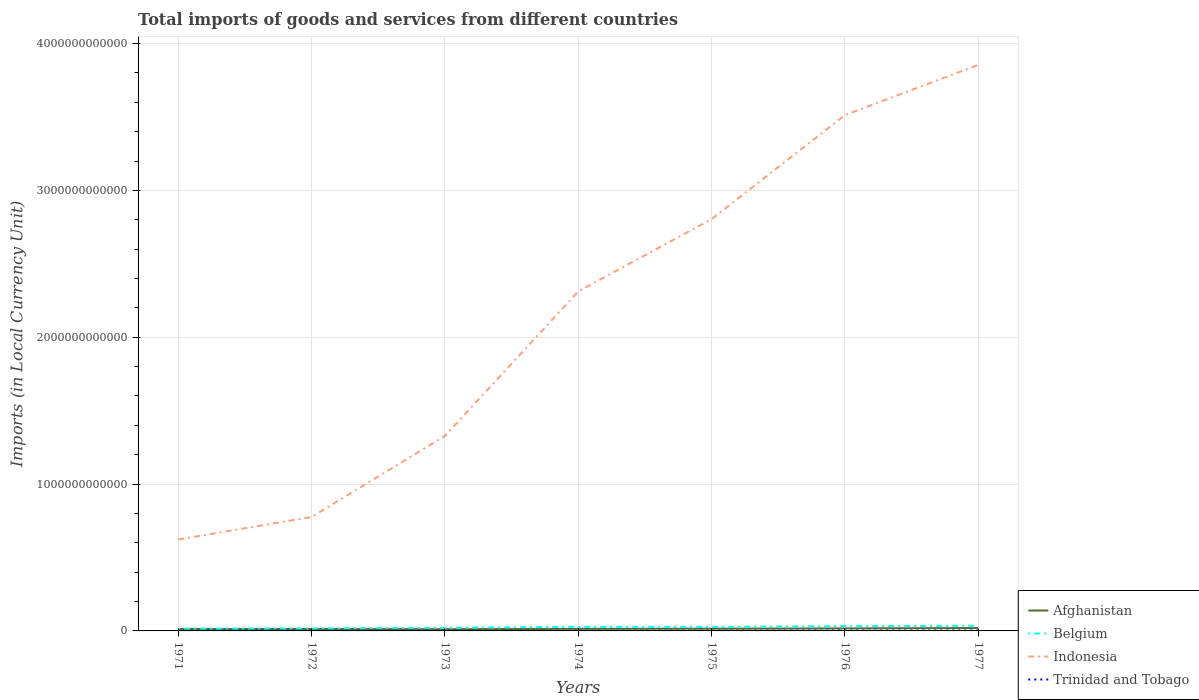How many different coloured lines are there?
Your response must be concise. 4. Across all years, what is the maximum Amount of goods and services imports in Trinidad and Tobago?
Provide a succinct answer. 8.48e+08. What is the total Amount of goods and services imports in Indonesia in the graph?
Your answer should be compact. -7.05e+11. What is the difference between the highest and the second highest Amount of goods and services imports in Trinidad and Tobago?
Keep it short and to the point. 1.93e+09. What is the difference between the highest and the lowest Amount of goods and services imports in Trinidad and Tobago?
Offer a very short reply. 3. Is the Amount of goods and services imports in Belgium strictly greater than the Amount of goods and services imports in Trinidad and Tobago over the years?
Your answer should be very brief. No. How many lines are there?
Make the answer very short. 4. How many years are there in the graph?
Ensure brevity in your answer.  7. What is the difference between two consecutive major ticks on the Y-axis?
Your answer should be compact. 1.00e+12. Does the graph contain any zero values?
Offer a very short reply. No. Does the graph contain grids?
Provide a short and direct response. Yes. What is the title of the graph?
Make the answer very short. Total imports of goods and services from different countries. What is the label or title of the Y-axis?
Ensure brevity in your answer.  Imports (in Local Currency Unit). What is the Imports (in Local Currency Unit) of Afghanistan in 1971?
Offer a terse response. 1.33e+1. What is the Imports (in Local Currency Unit) in Belgium in 1971?
Offer a very short reply. 1.52e+1. What is the Imports (in Local Currency Unit) of Indonesia in 1971?
Give a very brief answer. 6.22e+11. What is the Imports (in Local Currency Unit) of Trinidad and Tobago in 1971?
Ensure brevity in your answer.  8.48e+08. What is the Imports (in Local Currency Unit) in Afghanistan in 1972?
Your response must be concise. 1.30e+1. What is the Imports (in Local Currency Unit) in Belgium in 1972?
Ensure brevity in your answer.  1.67e+1. What is the Imports (in Local Currency Unit) in Indonesia in 1972?
Provide a short and direct response. 7.76e+11. What is the Imports (in Local Currency Unit) in Trinidad and Tobago in 1972?
Give a very brief answer. 9.63e+08. What is the Imports (in Local Currency Unit) in Afghanistan in 1973?
Give a very brief answer. 1.15e+1. What is the Imports (in Local Currency Unit) of Belgium in 1973?
Make the answer very short. 2.13e+1. What is the Imports (in Local Currency Unit) of Indonesia in 1973?
Provide a short and direct response. 1.33e+12. What is the Imports (in Local Currency Unit) of Trinidad and Tobago in 1973?
Offer a terse response. 9.84e+08. What is the Imports (in Local Currency Unit) of Afghanistan in 1974?
Your answer should be very brief. 1.44e+1. What is the Imports (in Local Currency Unit) in Belgium in 1974?
Give a very brief answer. 2.84e+1. What is the Imports (in Local Currency Unit) of Indonesia in 1974?
Offer a terse response. 2.31e+12. What is the Imports (in Local Currency Unit) in Trinidad and Tobago in 1974?
Your answer should be very brief. 1.35e+09. What is the Imports (in Local Currency Unit) in Afghanistan in 1975?
Your response must be concise. 1.52e+1. What is the Imports (in Local Currency Unit) in Belgium in 1975?
Provide a succinct answer. 2.73e+1. What is the Imports (in Local Currency Unit) of Indonesia in 1975?
Keep it short and to the point. 2.80e+12. What is the Imports (in Local Currency Unit) of Trinidad and Tobago in 1975?
Give a very brief answer. 1.87e+09. What is the Imports (in Local Currency Unit) in Afghanistan in 1976?
Give a very brief answer. 1.71e+1. What is the Imports (in Local Currency Unit) in Belgium in 1976?
Your response must be concise. 3.29e+1. What is the Imports (in Local Currency Unit) in Indonesia in 1976?
Provide a short and direct response. 3.51e+12. What is the Imports (in Local Currency Unit) in Trinidad and Tobago in 1976?
Your answer should be very brief. 2.44e+09. What is the Imports (in Local Currency Unit) of Afghanistan in 1977?
Your answer should be very brief. 1.97e+1. What is the Imports (in Local Currency Unit) of Belgium in 1977?
Provide a short and direct response. 3.55e+1. What is the Imports (in Local Currency Unit) in Indonesia in 1977?
Your answer should be very brief. 3.86e+12. What is the Imports (in Local Currency Unit) in Trinidad and Tobago in 1977?
Offer a terse response. 2.78e+09. Across all years, what is the maximum Imports (in Local Currency Unit) in Afghanistan?
Give a very brief answer. 1.97e+1. Across all years, what is the maximum Imports (in Local Currency Unit) in Belgium?
Offer a terse response. 3.55e+1. Across all years, what is the maximum Imports (in Local Currency Unit) in Indonesia?
Provide a succinct answer. 3.86e+12. Across all years, what is the maximum Imports (in Local Currency Unit) of Trinidad and Tobago?
Provide a short and direct response. 2.78e+09. Across all years, what is the minimum Imports (in Local Currency Unit) in Afghanistan?
Make the answer very short. 1.15e+1. Across all years, what is the minimum Imports (in Local Currency Unit) in Belgium?
Ensure brevity in your answer.  1.52e+1. Across all years, what is the minimum Imports (in Local Currency Unit) in Indonesia?
Give a very brief answer. 6.22e+11. Across all years, what is the minimum Imports (in Local Currency Unit) of Trinidad and Tobago?
Make the answer very short. 8.48e+08. What is the total Imports (in Local Currency Unit) of Afghanistan in the graph?
Give a very brief answer. 1.04e+11. What is the total Imports (in Local Currency Unit) of Belgium in the graph?
Keep it short and to the point. 1.77e+11. What is the total Imports (in Local Currency Unit) in Indonesia in the graph?
Offer a terse response. 1.52e+13. What is the total Imports (in Local Currency Unit) of Trinidad and Tobago in the graph?
Offer a very short reply. 1.12e+1. What is the difference between the Imports (in Local Currency Unit) in Afghanistan in 1971 and that in 1972?
Provide a short and direct response. 3.00e+08. What is the difference between the Imports (in Local Currency Unit) of Belgium in 1971 and that in 1972?
Offer a very short reply. -1.51e+09. What is the difference between the Imports (in Local Currency Unit) in Indonesia in 1971 and that in 1972?
Offer a very short reply. -1.54e+11. What is the difference between the Imports (in Local Currency Unit) in Trinidad and Tobago in 1971 and that in 1972?
Your response must be concise. -1.15e+08. What is the difference between the Imports (in Local Currency Unit) in Afghanistan in 1971 and that in 1973?
Make the answer very short. 1.80e+09. What is the difference between the Imports (in Local Currency Unit) in Belgium in 1971 and that in 1973?
Offer a very short reply. -6.11e+09. What is the difference between the Imports (in Local Currency Unit) of Indonesia in 1971 and that in 1973?
Your answer should be compact. -7.05e+11. What is the difference between the Imports (in Local Currency Unit) of Trinidad and Tobago in 1971 and that in 1973?
Provide a short and direct response. -1.36e+08. What is the difference between the Imports (in Local Currency Unit) of Afghanistan in 1971 and that in 1974?
Make the answer very short. -1.10e+09. What is the difference between the Imports (in Local Currency Unit) of Belgium in 1971 and that in 1974?
Offer a terse response. -1.32e+1. What is the difference between the Imports (in Local Currency Unit) of Indonesia in 1971 and that in 1974?
Provide a short and direct response. -1.69e+12. What is the difference between the Imports (in Local Currency Unit) of Trinidad and Tobago in 1971 and that in 1974?
Provide a short and direct response. -5.01e+08. What is the difference between the Imports (in Local Currency Unit) of Afghanistan in 1971 and that in 1975?
Give a very brief answer. -1.90e+09. What is the difference between the Imports (in Local Currency Unit) in Belgium in 1971 and that in 1975?
Make the answer very short. -1.22e+1. What is the difference between the Imports (in Local Currency Unit) in Indonesia in 1971 and that in 1975?
Keep it short and to the point. -2.18e+12. What is the difference between the Imports (in Local Currency Unit) in Trinidad and Tobago in 1971 and that in 1975?
Ensure brevity in your answer.  -1.02e+09. What is the difference between the Imports (in Local Currency Unit) of Afghanistan in 1971 and that in 1976?
Offer a very short reply. -3.80e+09. What is the difference between the Imports (in Local Currency Unit) of Belgium in 1971 and that in 1976?
Keep it short and to the point. -1.77e+1. What is the difference between the Imports (in Local Currency Unit) in Indonesia in 1971 and that in 1976?
Offer a very short reply. -2.89e+12. What is the difference between the Imports (in Local Currency Unit) in Trinidad and Tobago in 1971 and that in 1976?
Give a very brief answer. -1.60e+09. What is the difference between the Imports (in Local Currency Unit) of Afghanistan in 1971 and that in 1977?
Provide a succinct answer. -6.40e+09. What is the difference between the Imports (in Local Currency Unit) of Belgium in 1971 and that in 1977?
Offer a terse response. -2.03e+1. What is the difference between the Imports (in Local Currency Unit) in Indonesia in 1971 and that in 1977?
Offer a terse response. -3.23e+12. What is the difference between the Imports (in Local Currency Unit) in Trinidad and Tobago in 1971 and that in 1977?
Your response must be concise. -1.93e+09. What is the difference between the Imports (in Local Currency Unit) of Afghanistan in 1972 and that in 1973?
Your response must be concise. 1.50e+09. What is the difference between the Imports (in Local Currency Unit) of Belgium in 1972 and that in 1973?
Keep it short and to the point. -4.60e+09. What is the difference between the Imports (in Local Currency Unit) of Indonesia in 1972 and that in 1973?
Offer a terse response. -5.52e+11. What is the difference between the Imports (in Local Currency Unit) in Trinidad and Tobago in 1972 and that in 1973?
Give a very brief answer. -2.09e+07. What is the difference between the Imports (in Local Currency Unit) in Afghanistan in 1972 and that in 1974?
Keep it short and to the point. -1.40e+09. What is the difference between the Imports (in Local Currency Unit) in Belgium in 1972 and that in 1974?
Offer a very short reply. -1.17e+1. What is the difference between the Imports (in Local Currency Unit) in Indonesia in 1972 and that in 1974?
Offer a very short reply. -1.54e+12. What is the difference between the Imports (in Local Currency Unit) in Trinidad and Tobago in 1972 and that in 1974?
Offer a terse response. -3.87e+08. What is the difference between the Imports (in Local Currency Unit) in Afghanistan in 1972 and that in 1975?
Give a very brief answer. -2.20e+09. What is the difference between the Imports (in Local Currency Unit) of Belgium in 1972 and that in 1975?
Make the answer very short. -1.06e+1. What is the difference between the Imports (in Local Currency Unit) of Indonesia in 1972 and that in 1975?
Your answer should be compact. -2.03e+12. What is the difference between the Imports (in Local Currency Unit) of Trinidad and Tobago in 1972 and that in 1975?
Give a very brief answer. -9.03e+08. What is the difference between the Imports (in Local Currency Unit) in Afghanistan in 1972 and that in 1976?
Give a very brief answer. -4.10e+09. What is the difference between the Imports (in Local Currency Unit) of Belgium in 1972 and that in 1976?
Offer a terse response. -1.62e+1. What is the difference between the Imports (in Local Currency Unit) of Indonesia in 1972 and that in 1976?
Provide a short and direct response. -2.74e+12. What is the difference between the Imports (in Local Currency Unit) in Trinidad and Tobago in 1972 and that in 1976?
Keep it short and to the point. -1.48e+09. What is the difference between the Imports (in Local Currency Unit) in Afghanistan in 1972 and that in 1977?
Offer a terse response. -6.70e+09. What is the difference between the Imports (in Local Currency Unit) of Belgium in 1972 and that in 1977?
Make the answer very short. -1.88e+1. What is the difference between the Imports (in Local Currency Unit) of Indonesia in 1972 and that in 1977?
Your response must be concise. -3.08e+12. What is the difference between the Imports (in Local Currency Unit) in Trinidad and Tobago in 1972 and that in 1977?
Ensure brevity in your answer.  -1.82e+09. What is the difference between the Imports (in Local Currency Unit) in Afghanistan in 1973 and that in 1974?
Offer a very short reply. -2.90e+09. What is the difference between the Imports (in Local Currency Unit) in Belgium in 1973 and that in 1974?
Provide a succinct answer. -7.08e+09. What is the difference between the Imports (in Local Currency Unit) in Indonesia in 1973 and that in 1974?
Your response must be concise. -9.84e+11. What is the difference between the Imports (in Local Currency Unit) of Trinidad and Tobago in 1973 and that in 1974?
Offer a very short reply. -3.66e+08. What is the difference between the Imports (in Local Currency Unit) of Afghanistan in 1973 and that in 1975?
Your response must be concise. -3.70e+09. What is the difference between the Imports (in Local Currency Unit) of Belgium in 1973 and that in 1975?
Ensure brevity in your answer.  -6.04e+09. What is the difference between the Imports (in Local Currency Unit) of Indonesia in 1973 and that in 1975?
Ensure brevity in your answer.  -1.48e+12. What is the difference between the Imports (in Local Currency Unit) in Trinidad and Tobago in 1973 and that in 1975?
Your answer should be very brief. -8.82e+08. What is the difference between the Imports (in Local Currency Unit) in Afghanistan in 1973 and that in 1976?
Ensure brevity in your answer.  -5.60e+09. What is the difference between the Imports (in Local Currency Unit) in Belgium in 1973 and that in 1976?
Make the answer very short. -1.16e+1. What is the difference between the Imports (in Local Currency Unit) of Indonesia in 1973 and that in 1976?
Your answer should be very brief. -2.19e+12. What is the difference between the Imports (in Local Currency Unit) of Trinidad and Tobago in 1973 and that in 1976?
Offer a very short reply. -1.46e+09. What is the difference between the Imports (in Local Currency Unit) in Afghanistan in 1973 and that in 1977?
Provide a succinct answer. -8.20e+09. What is the difference between the Imports (in Local Currency Unit) of Belgium in 1973 and that in 1977?
Give a very brief answer. -1.42e+1. What is the difference between the Imports (in Local Currency Unit) in Indonesia in 1973 and that in 1977?
Ensure brevity in your answer.  -2.53e+12. What is the difference between the Imports (in Local Currency Unit) of Trinidad and Tobago in 1973 and that in 1977?
Keep it short and to the point. -1.80e+09. What is the difference between the Imports (in Local Currency Unit) in Afghanistan in 1974 and that in 1975?
Offer a terse response. -8.00e+08. What is the difference between the Imports (in Local Currency Unit) in Belgium in 1974 and that in 1975?
Your answer should be compact. 1.03e+09. What is the difference between the Imports (in Local Currency Unit) of Indonesia in 1974 and that in 1975?
Your answer should be compact. -4.93e+11. What is the difference between the Imports (in Local Currency Unit) of Trinidad and Tobago in 1974 and that in 1975?
Offer a terse response. -5.16e+08. What is the difference between the Imports (in Local Currency Unit) in Afghanistan in 1974 and that in 1976?
Your answer should be very brief. -2.70e+09. What is the difference between the Imports (in Local Currency Unit) of Belgium in 1974 and that in 1976?
Your answer should be very brief. -4.51e+09. What is the difference between the Imports (in Local Currency Unit) in Indonesia in 1974 and that in 1976?
Offer a very short reply. -1.20e+12. What is the difference between the Imports (in Local Currency Unit) of Trinidad and Tobago in 1974 and that in 1976?
Provide a succinct answer. -1.10e+09. What is the difference between the Imports (in Local Currency Unit) in Afghanistan in 1974 and that in 1977?
Keep it short and to the point. -5.30e+09. What is the difference between the Imports (in Local Currency Unit) of Belgium in 1974 and that in 1977?
Keep it short and to the point. -7.12e+09. What is the difference between the Imports (in Local Currency Unit) of Indonesia in 1974 and that in 1977?
Give a very brief answer. -1.54e+12. What is the difference between the Imports (in Local Currency Unit) of Trinidad and Tobago in 1974 and that in 1977?
Offer a terse response. -1.43e+09. What is the difference between the Imports (in Local Currency Unit) in Afghanistan in 1975 and that in 1976?
Offer a very short reply. -1.90e+09. What is the difference between the Imports (in Local Currency Unit) of Belgium in 1975 and that in 1976?
Your response must be concise. -5.54e+09. What is the difference between the Imports (in Local Currency Unit) in Indonesia in 1975 and that in 1976?
Your response must be concise. -7.08e+11. What is the difference between the Imports (in Local Currency Unit) in Trinidad and Tobago in 1975 and that in 1976?
Your response must be concise. -5.79e+08. What is the difference between the Imports (in Local Currency Unit) in Afghanistan in 1975 and that in 1977?
Offer a terse response. -4.50e+09. What is the difference between the Imports (in Local Currency Unit) in Belgium in 1975 and that in 1977?
Your response must be concise. -8.15e+09. What is the difference between the Imports (in Local Currency Unit) of Indonesia in 1975 and that in 1977?
Make the answer very short. -1.05e+12. What is the difference between the Imports (in Local Currency Unit) in Trinidad and Tobago in 1975 and that in 1977?
Offer a very short reply. -9.14e+08. What is the difference between the Imports (in Local Currency Unit) in Afghanistan in 1976 and that in 1977?
Your answer should be compact. -2.60e+09. What is the difference between the Imports (in Local Currency Unit) in Belgium in 1976 and that in 1977?
Your answer should be compact. -2.61e+09. What is the difference between the Imports (in Local Currency Unit) of Indonesia in 1976 and that in 1977?
Provide a short and direct response. -3.42e+11. What is the difference between the Imports (in Local Currency Unit) in Trinidad and Tobago in 1976 and that in 1977?
Your answer should be very brief. -3.35e+08. What is the difference between the Imports (in Local Currency Unit) of Afghanistan in 1971 and the Imports (in Local Currency Unit) of Belgium in 1972?
Ensure brevity in your answer.  -3.39e+09. What is the difference between the Imports (in Local Currency Unit) in Afghanistan in 1971 and the Imports (in Local Currency Unit) in Indonesia in 1972?
Offer a terse response. -7.63e+11. What is the difference between the Imports (in Local Currency Unit) of Afghanistan in 1971 and the Imports (in Local Currency Unit) of Trinidad and Tobago in 1972?
Keep it short and to the point. 1.23e+1. What is the difference between the Imports (in Local Currency Unit) of Belgium in 1971 and the Imports (in Local Currency Unit) of Indonesia in 1972?
Your answer should be compact. -7.61e+11. What is the difference between the Imports (in Local Currency Unit) in Belgium in 1971 and the Imports (in Local Currency Unit) in Trinidad and Tobago in 1972?
Give a very brief answer. 1.42e+1. What is the difference between the Imports (in Local Currency Unit) in Indonesia in 1971 and the Imports (in Local Currency Unit) in Trinidad and Tobago in 1972?
Your answer should be very brief. 6.21e+11. What is the difference between the Imports (in Local Currency Unit) in Afghanistan in 1971 and the Imports (in Local Currency Unit) in Belgium in 1973?
Your answer should be very brief. -7.99e+09. What is the difference between the Imports (in Local Currency Unit) in Afghanistan in 1971 and the Imports (in Local Currency Unit) in Indonesia in 1973?
Keep it short and to the point. -1.31e+12. What is the difference between the Imports (in Local Currency Unit) in Afghanistan in 1971 and the Imports (in Local Currency Unit) in Trinidad and Tobago in 1973?
Make the answer very short. 1.23e+1. What is the difference between the Imports (in Local Currency Unit) of Belgium in 1971 and the Imports (in Local Currency Unit) of Indonesia in 1973?
Your response must be concise. -1.31e+12. What is the difference between the Imports (in Local Currency Unit) in Belgium in 1971 and the Imports (in Local Currency Unit) in Trinidad and Tobago in 1973?
Your answer should be very brief. 1.42e+1. What is the difference between the Imports (in Local Currency Unit) in Indonesia in 1971 and the Imports (in Local Currency Unit) in Trinidad and Tobago in 1973?
Your answer should be very brief. 6.21e+11. What is the difference between the Imports (in Local Currency Unit) in Afghanistan in 1971 and the Imports (in Local Currency Unit) in Belgium in 1974?
Offer a very short reply. -1.51e+1. What is the difference between the Imports (in Local Currency Unit) in Afghanistan in 1971 and the Imports (in Local Currency Unit) in Indonesia in 1974?
Offer a very short reply. -2.30e+12. What is the difference between the Imports (in Local Currency Unit) in Afghanistan in 1971 and the Imports (in Local Currency Unit) in Trinidad and Tobago in 1974?
Ensure brevity in your answer.  1.20e+1. What is the difference between the Imports (in Local Currency Unit) of Belgium in 1971 and the Imports (in Local Currency Unit) of Indonesia in 1974?
Offer a very short reply. -2.30e+12. What is the difference between the Imports (in Local Currency Unit) of Belgium in 1971 and the Imports (in Local Currency Unit) of Trinidad and Tobago in 1974?
Provide a short and direct response. 1.38e+1. What is the difference between the Imports (in Local Currency Unit) in Indonesia in 1971 and the Imports (in Local Currency Unit) in Trinidad and Tobago in 1974?
Give a very brief answer. 6.21e+11. What is the difference between the Imports (in Local Currency Unit) of Afghanistan in 1971 and the Imports (in Local Currency Unit) of Belgium in 1975?
Offer a very short reply. -1.40e+1. What is the difference between the Imports (in Local Currency Unit) of Afghanistan in 1971 and the Imports (in Local Currency Unit) of Indonesia in 1975?
Give a very brief answer. -2.79e+12. What is the difference between the Imports (in Local Currency Unit) in Afghanistan in 1971 and the Imports (in Local Currency Unit) in Trinidad and Tobago in 1975?
Ensure brevity in your answer.  1.14e+1. What is the difference between the Imports (in Local Currency Unit) of Belgium in 1971 and the Imports (in Local Currency Unit) of Indonesia in 1975?
Your answer should be compact. -2.79e+12. What is the difference between the Imports (in Local Currency Unit) in Belgium in 1971 and the Imports (in Local Currency Unit) in Trinidad and Tobago in 1975?
Your response must be concise. 1.33e+1. What is the difference between the Imports (in Local Currency Unit) in Indonesia in 1971 and the Imports (in Local Currency Unit) in Trinidad and Tobago in 1975?
Your response must be concise. 6.21e+11. What is the difference between the Imports (in Local Currency Unit) in Afghanistan in 1971 and the Imports (in Local Currency Unit) in Belgium in 1976?
Ensure brevity in your answer.  -1.96e+1. What is the difference between the Imports (in Local Currency Unit) in Afghanistan in 1971 and the Imports (in Local Currency Unit) in Indonesia in 1976?
Your answer should be very brief. -3.50e+12. What is the difference between the Imports (in Local Currency Unit) in Afghanistan in 1971 and the Imports (in Local Currency Unit) in Trinidad and Tobago in 1976?
Your answer should be compact. 1.09e+1. What is the difference between the Imports (in Local Currency Unit) in Belgium in 1971 and the Imports (in Local Currency Unit) in Indonesia in 1976?
Offer a very short reply. -3.50e+12. What is the difference between the Imports (in Local Currency Unit) in Belgium in 1971 and the Imports (in Local Currency Unit) in Trinidad and Tobago in 1976?
Your answer should be compact. 1.27e+1. What is the difference between the Imports (in Local Currency Unit) of Indonesia in 1971 and the Imports (in Local Currency Unit) of Trinidad and Tobago in 1976?
Provide a succinct answer. 6.20e+11. What is the difference between the Imports (in Local Currency Unit) of Afghanistan in 1971 and the Imports (in Local Currency Unit) of Belgium in 1977?
Give a very brief answer. -2.22e+1. What is the difference between the Imports (in Local Currency Unit) of Afghanistan in 1971 and the Imports (in Local Currency Unit) of Indonesia in 1977?
Your answer should be compact. -3.84e+12. What is the difference between the Imports (in Local Currency Unit) in Afghanistan in 1971 and the Imports (in Local Currency Unit) in Trinidad and Tobago in 1977?
Your answer should be compact. 1.05e+1. What is the difference between the Imports (in Local Currency Unit) in Belgium in 1971 and the Imports (in Local Currency Unit) in Indonesia in 1977?
Give a very brief answer. -3.84e+12. What is the difference between the Imports (in Local Currency Unit) in Belgium in 1971 and the Imports (in Local Currency Unit) in Trinidad and Tobago in 1977?
Offer a terse response. 1.24e+1. What is the difference between the Imports (in Local Currency Unit) of Indonesia in 1971 and the Imports (in Local Currency Unit) of Trinidad and Tobago in 1977?
Your response must be concise. 6.20e+11. What is the difference between the Imports (in Local Currency Unit) in Afghanistan in 1972 and the Imports (in Local Currency Unit) in Belgium in 1973?
Make the answer very short. -8.29e+09. What is the difference between the Imports (in Local Currency Unit) in Afghanistan in 1972 and the Imports (in Local Currency Unit) in Indonesia in 1973?
Ensure brevity in your answer.  -1.31e+12. What is the difference between the Imports (in Local Currency Unit) of Afghanistan in 1972 and the Imports (in Local Currency Unit) of Trinidad and Tobago in 1973?
Keep it short and to the point. 1.20e+1. What is the difference between the Imports (in Local Currency Unit) in Belgium in 1972 and the Imports (in Local Currency Unit) in Indonesia in 1973?
Ensure brevity in your answer.  -1.31e+12. What is the difference between the Imports (in Local Currency Unit) of Belgium in 1972 and the Imports (in Local Currency Unit) of Trinidad and Tobago in 1973?
Your answer should be compact. 1.57e+1. What is the difference between the Imports (in Local Currency Unit) of Indonesia in 1972 and the Imports (in Local Currency Unit) of Trinidad and Tobago in 1973?
Make the answer very short. 7.75e+11. What is the difference between the Imports (in Local Currency Unit) of Afghanistan in 1972 and the Imports (in Local Currency Unit) of Belgium in 1974?
Keep it short and to the point. -1.54e+1. What is the difference between the Imports (in Local Currency Unit) of Afghanistan in 1972 and the Imports (in Local Currency Unit) of Indonesia in 1974?
Make the answer very short. -2.30e+12. What is the difference between the Imports (in Local Currency Unit) of Afghanistan in 1972 and the Imports (in Local Currency Unit) of Trinidad and Tobago in 1974?
Offer a terse response. 1.17e+1. What is the difference between the Imports (in Local Currency Unit) in Belgium in 1972 and the Imports (in Local Currency Unit) in Indonesia in 1974?
Give a very brief answer. -2.30e+12. What is the difference between the Imports (in Local Currency Unit) in Belgium in 1972 and the Imports (in Local Currency Unit) in Trinidad and Tobago in 1974?
Give a very brief answer. 1.53e+1. What is the difference between the Imports (in Local Currency Unit) of Indonesia in 1972 and the Imports (in Local Currency Unit) of Trinidad and Tobago in 1974?
Provide a succinct answer. 7.75e+11. What is the difference between the Imports (in Local Currency Unit) of Afghanistan in 1972 and the Imports (in Local Currency Unit) of Belgium in 1975?
Provide a short and direct response. -1.43e+1. What is the difference between the Imports (in Local Currency Unit) of Afghanistan in 1972 and the Imports (in Local Currency Unit) of Indonesia in 1975?
Your response must be concise. -2.79e+12. What is the difference between the Imports (in Local Currency Unit) in Afghanistan in 1972 and the Imports (in Local Currency Unit) in Trinidad and Tobago in 1975?
Your answer should be compact. 1.11e+1. What is the difference between the Imports (in Local Currency Unit) in Belgium in 1972 and the Imports (in Local Currency Unit) in Indonesia in 1975?
Provide a short and direct response. -2.79e+12. What is the difference between the Imports (in Local Currency Unit) of Belgium in 1972 and the Imports (in Local Currency Unit) of Trinidad and Tobago in 1975?
Provide a short and direct response. 1.48e+1. What is the difference between the Imports (in Local Currency Unit) of Indonesia in 1972 and the Imports (in Local Currency Unit) of Trinidad and Tobago in 1975?
Ensure brevity in your answer.  7.74e+11. What is the difference between the Imports (in Local Currency Unit) of Afghanistan in 1972 and the Imports (in Local Currency Unit) of Belgium in 1976?
Provide a short and direct response. -1.99e+1. What is the difference between the Imports (in Local Currency Unit) in Afghanistan in 1972 and the Imports (in Local Currency Unit) in Indonesia in 1976?
Your answer should be very brief. -3.50e+12. What is the difference between the Imports (in Local Currency Unit) of Afghanistan in 1972 and the Imports (in Local Currency Unit) of Trinidad and Tobago in 1976?
Provide a succinct answer. 1.06e+1. What is the difference between the Imports (in Local Currency Unit) in Belgium in 1972 and the Imports (in Local Currency Unit) in Indonesia in 1976?
Your answer should be very brief. -3.50e+12. What is the difference between the Imports (in Local Currency Unit) in Belgium in 1972 and the Imports (in Local Currency Unit) in Trinidad and Tobago in 1976?
Give a very brief answer. 1.42e+1. What is the difference between the Imports (in Local Currency Unit) in Indonesia in 1972 and the Imports (in Local Currency Unit) in Trinidad and Tobago in 1976?
Offer a terse response. 7.74e+11. What is the difference between the Imports (in Local Currency Unit) of Afghanistan in 1972 and the Imports (in Local Currency Unit) of Belgium in 1977?
Keep it short and to the point. -2.25e+1. What is the difference between the Imports (in Local Currency Unit) in Afghanistan in 1972 and the Imports (in Local Currency Unit) in Indonesia in 1977?
Your answer should be compact. -3.84e+12. What is the difference between the Imports (in Local Currency Unit) of Afghanistan in 1972 and the Imports (in Local Currency Unit) of Trinidad and Tobago in 1977?
Make the answer very short. 1.02e+1. What is the difference between the Imports (in Local Currency Unit) in Belgium in 1972 and the Imports (in Local Currency Unit) in Indonesia in 1977?
Your answer should be compact. -3.84e+12. What is the difference between the Imports (in Local Currency Unit) in Belgium in 1972 and the Imports (in Local Currency Unit) in Trinidad and Tobago in 1977?
Your response must be concise. 1.39e+1. What is the difference between the Imports (in Local Currency Unit) in Indonesia in 1972 and the Imports (in Local Currency Unit) in Trinidad and Tobago in 1977?
Your answer should be compact. 7.73e+11. What is the difference between the Imports (in Local Currency Unit) of Afghanistan in 1973 and the Imports (in Local Currency Unit) of Belgium in 1974?
Your response must be concise. -1.69e+1. What is the difference between the Imports (in Local Currency Unit) in Afghanistan in 1973 and the Imports (in Local Currency Unit) in Indonesia in 1974?
Your response must be concise. -2.30e+12. What is the difference between the Imports (in Local Currency Unit) of Afghanistan in 1973 and the Imports (in Local Currency Unit) of Trinidad and Tobago in 1974?
Your response must be concise. 1.02e+1. What is the difference between the Imports (in Local Currency Unit) in Belgium in 1973 and the Imports (in Local Currency Unit) in Indonesia in 1974?
Give a very brief answer. -2.29e+12. What is the difference between the Imports (in Local Currency Unit) of Belgium in 1973 and the Imports (in Local Currency Unit) of Trinidad and Tobago in 1974?
Make the answer very short. 1.99e+1. What is the difference between the Imports (in Local Currency Unit) in Indonesia in 1973 and the Imports (in Local Currency Unit) in Trinidad and Tobago in 1974?
Your answer should be very brief. 1.33e+12. What is the difference between the Imports (in Local Currency Unit) of Afghanistan in 1973 and the Imports (in Local Currency Unit) of Belgium in 1975?
Your answer should be very brief. -1.58e+1. What is the difference between the Imports (in Local Currency Unit) of Afghanistan in 1973 and the Imports (in Local Currency Unit) of Indonesia in 1975?
Make the answer very short. -2.79e+12. What is the difference between the Imports (in Local Currency Unit) of Afghanistan in 1973 and the Imports (in Local Currency Unit) of Trinidad and Tobago in 1975?
Offer a terse response. 9.63e+09. What is the difference between the Imports (in Local Currency Unit) in Belgium in 1973 and the Imports (in Local Currency Unit) in Indonesia in 1975?
Provide a succinct answer. -2.78e+12. What is the difference between the Imports (in Local Currency Unit) in Belgium in 1973 and the Imports (in Local Currency Unit) in Trinidad and Tobago in 1975?
Keep it short and to the point. 1.94e+1. What is the difference between the Imports (in Local Currency Unit) of Indonesia in 1973 and the Imports (in Local Currency Unit) of Trinidad and Tobago in 1975?
Ensure brevity in your answer.  1.33e+12. What is the difference between the Imports (in Local Currency Unit) in Afghanistan in 1973 and the Imports (in Local Currency Unit) in Belgium in 1976?
Give a very brief answer. -2.14e+1. What is the difference between the Imports (in Local Currency Unit) in Afghanistan in 1973 and the Imports (in Local Currency Unit) in Indonesia in 1976?
Keep it short and to the point. -3.50e+12. What is the difference between the Imports (in Local Currency Unit) of Afghanistan in 1973 and the Imports (in Local Currency Unit) of Trinidad and Tobago in 1976?
Your answer should be very brief. 9.06e+09. What is the difference between the Imports (in Local Currency Unit) in Belgium in 1973 and the Imports (in Local Currency Unit) in Indonesia in 1976?
Ensure brevity in your answer.  -3.49e+12. What is the difference between the Imports (in Local Currency Unit) of Belgium in 1973 and the Imports (in Local Currency Unit) of Trinidad and Tobago in 1976?
Your answer should be compact. 1.88e+1. What is the difference between the Imports (in Local Currency Unit) of Indonesia in 1973 and the Imports (in Local Currency Unit) of Trinidad and Tobago in 1976?
Offer a very short reply. 1.33e+12. What is the difference between the Imports (in Local Currency Unit) of Afghanistan in 1973 and the Imports (in Local Currency Unit) of Belgium in 1977?
Keep it short and to the point. -2.40e+1. What is the difference between the Imports (in Local Currency Unit) in Afghanistan in 1973 and the Imports (in Local Currency Unit) in Indonesia in 1977?
Offer a terse response. -3.84e+12. What is the difference between the Imports (in Local Currency Unit) in Afghanistan in 1973 and the Imports (in Local Currency Unit) in Trinidad and Tobago in 1977?
Give a very brief answer. 8.72e+09. What is the difference between the Imports (in Local Currency Unit) in Belgium in 1973 and the Imports (in Local Currency Unit) in Indonesia in 1977?
Keep it short and to the point. -3.83e+12. What is the difference between the Imports (in Local Currency Unit) of Belgium in 1973 and the Imports (in Local Currency Unit) of Trinidad and Tobago in 1977?
Give a very brief answer. 1.85e+1. What is the difference between the Imports (in Local Currency Unit) in Indonesia in 1973 and the Imports (in Local Currency Unit) in Trinidad and Tobago in 1977?
Your answer should be very brief. 1.32e+12. What is the difference between the Imports (in Local Currency Unit) in Afghanistan in 1974 and the Imports (in Local Currency Unit) in Belgium in 1975?
Offer a very short reply. -1.29e+1. What is the difference between the Imports (in Local Currency Unit) in Afghanistan in 1974 and the Imports (in Local Currency Unit) in Indonesia in 1975?
Offer a very short reply. -2.79e+12. What is the difference between the Imports (in Local Currency Unit) of Afghanistan in 1974 and the Imports (in Local Currency Unit) of Trinidad and Tobago in 1975?
Your answer should be very brief. 1.25e+1. What is the difference between the Imports (in Local Currency Unit) of Belgium in 1974 and the Imports (in Local Currency Unit) of Indonesia in 1975?
Ensure brevity in your answer.  -2.78e+12. What is the difference between the Imports (in Local Currency Unit) in Belgium in 1974 and the Imports (in Local Currency Unit) in Trinidad and Tobago in 1975?
Provide a short and direct response. 2.65e+1. What is the difference between the Imports (in Local Currency Unit) of Indonesia in 1974 and the Imports (in Local Currency Unit) of Trinidad and Tobago in 1975?
Offer a very short reply. 2.31e+12. What is the difference between the Imports (in Local Currency Unit) in Afghanistan in 1974 and the Imports (in Local Currency Unit) in Belgium in 1976?
Your answer should be compact. -1.85e+1. What is the difference between the Imports (in Local Currency Unit) of Afghanistan in 1974 and the Imports (in Local Currency Unit) of Indonesia in 1976?
Provide a short and direct response. -3.50e+12. What is the difference between the Imports (in Local Currency Unit) in Afghanistan in 1974 and the Imports (in Local Currency Unit) in Trinidad and Tobago in 1976?
Ensure brevity in your answer.  1.20e+1. What is the difference between the Imports (in Local Currency Unit) in Belgium in 1974 and the Imports (in Local Currency Unit) in Indonesia in 1976?
Ensure brevity in your answer.  -3.48e+12. What is the difference between the Imports (in Local Currency Unit) in Belgium in 1974 and the Imports (in Local Currency Unit) in Trinidad and Tobago in 1976?
Your response must be concise. 2.59e+1. What is the difference between the Imports (in Local Currency Unit) in Indonesia in 1974 and the Imports (in Local Currency Unit) in Trinidad and Tobago in 1976?
Keep it short and to the point. 2.31e+12. What is the difference between the Imports (in Local Currency Unit) in Afghanistan in 1974 and the Imports (in Local Currency Unit) in Belgium in 1977?
Provide a short and direct response. -2.11e+1. What is the difference between the Imports (in Local Currency Unit) of Afghanistan in 1974 and the Imports (in Local Currency Unit) of Indonesia in 1977?
Offer a very short reply. -3.84e+12. What is the difference between the Imports (in Local Currency Unit) of Afghanistan in 1974 and the Imports (in Local Currency Unit) of Trinidad and Tobago in 1977?
Your answer should be compact. 1.16e+1. What is the difference between the Imports (in Local Currency Unit) in Belgium in 1974 and the Imports (in Local Currency Unit) in Indonesia in 1977?
Ensure brevity in your answer.  -3.83e+12. What is the difference between the Imports (in Local Currency Unit) of Belgium in 1974 and the Imports (in Local Currency Unit) of Trinidad and Tobago in 1977?
Make the answer very short. 2.56e+1. What is the difference between the Imports (in Local Currency Unit) of Indonesia in 1974 and the Imports (in Local Currency Unit) of Trinidad and Tobago in 1977?
Offer a terse response. 2.31e+12. What is the difference between the Imports (in Local Currency Unit) of Afghanistan in 1975 and the Imports (in Local Currency Unit) of Belgium in 1976?
Provide a short and direct response. -1.77e+1. What is the difference between the Imports (in Local Currency Unit) in Afghanistan in 1975 and the Imports (in Local Currency Unit) in Indonesia in 1976?
Your answer should be compact. -3.50e+12. What is the difference between the Imports (in Local Currency Unit) in Afghanistan in 1975 and the Imports (in Local Currency Unit) in Trinidad and Tobago in 1976?
Your response must be concise. 1.28e+1. What is the difference between the Imports (in Local Currency Unit) of Belgium in 1975 and the Imports (in Local Currency Unit) of Indonesia in 1976?
Your answer should be very brief. -3.49e+12. What is the difference between the Imports (in Local Currency Unit) of Belgium in 1975 and the Imports (in Local Currency Unit) of Trinidad and Tobago in 1976?
Your response must be concise. 2.49e+1. What is the difference between the Imports (in Local Currency Unit) of Indonesia in 1975 and the Imports (in Local Currency Unit) of Trinidad and Tobago in 1976?
Make the answer very short. 2.80e+12. What is the difference between the Imports (in Local Currency Unit) in Afghanistan in 1975 and the Imports (in Local Currency Unit) in Belgium in 1977?
Make the answer very short. -2.03e+1. What is the difference between the Imports (in Local Currency Unit) of Afghanistan in 1975 and the Imports (in Local Currency Unit) of Indonesia in 1977?
Your response must be concise. -3.84e+12. What is the difference between the Imports (in Local Currency Unit) of Afghanistan in 1975 and the Imports (in Local Currency Unit) of Trinidad and Tobago in 1977?
Keep it short and to the point. 1.24e+1. What is the difference between the Imports (in Local Currency Unit) of Belgium in 1975 and the Imports (in Local Currency Unit) of Indonesia in 1977?
Keep it short and to the point. -3.83e+12. What is the difference between the Imports (in Local Currency Unit) in Belgium in 1975 and the Imports (in Local Currency Unit) in Trinidad and Tobago in 1977?
Your answer should be compact. 2.46e+1. What is the difference between the Imports (in Local Currency Unit) in Indonesia in 1975 and the Imports (in Local Currency Unit) in Trinidad and Tobago in 1977?
Ensure brevity in your answer.  2.80e+12. What is the difference between the Imports (in Local Currency Unit) of Afghanistan in 1976 and the Imports (in Local Currency Unit) of Belgium in 1977?
Your answer should be compact. -1.84e+1. What is the difference between the Imports (in Local Currency Unit) of Afghanistan in 1976 and the Imports (in Local Currency Unit) of Indonesia in 1977?
Keep it short and to the point. -3.84e+12. What is the difference between the Imports (in Local Currency Unit) in Afghanistan in 1976 and the Imports (in Local Currency Unit) in Trinidad and Tobago in 1977?
Offer a terse response. 1.43e+1. What is the difference between the Imports (in Local Currency Unit) of Belgium in 1976 and the Imports (in Local Currency Unit) of Indonesia in 1977?
Your response must be concise. -3.82e+12. What is the difference between the Imports (in Local Currency Unit) in Belgium in 1976 and the Imports (in Local Currency Unit) in Trinidad and Tobago in 1977?
Your answer should be compact. 3.01e+1. What is the difference between the Imports (in Local Currency Unit) in Indonesia in 1976 and the Imports (in Local Currency Unit) in Trinidad and Tobago in 1977?
Give a very brief answer. 3.51e+12. What is the average Imports (in Local Currency Unit) in Afghanistan per year?
Your answer should be compact. 1.49e+1. What is the average Imports (in Local Currency Unit) in Belgium per year?
Your answer should be very brief. 2.53e+1. What is the average Imports (in Local Currency Unit) of Indonesia per year?
Provide a succinct answer. 2.17e+12. What is the average Imports (in Local Currency Unit) in Trinidad and Tobago per year?
Provide a short and direct response. 1.60e+09. In the year 1971, what is the difference between the Imports (in Local Currency Unit) of Afghanistan and Imports (in Local Currency Unit) of Belgium?
Your answer should be compact. -1.88e+09. In the year 1971, what is the difference between the Imports (in Local Currency Unit) of Afghanistan and Imports (in Local Currency Unit) of Indonesia?
Your answer should be compact. -6.09e+11. In the year 1971, what is the difference between the Imports (in Local Currency Unit) of Afghanistan and Imports (in Local Currency Unit) of Trinidad and Tobago?
Keep it short and to the point. 1.25e+1. In the year 1971, what is the difference between the Imports (in Local Currency Unit) in Belgium and Imports (in Local Currency Unit) in Indonesia?
Your response must be concise. -6.07e+11. In the year 1971, what is the difference between the Imports (in Local Currency Unit) of Belgium and Imports (in Local Currency Unit) of Trinidad and Tobago?
Provide a succinct answer. 1.43e+1. In the year 1971, what is the difference between the Imports (in Local Currency Unit) in Indonesia and Imports (in Local Currency Unit) in Trinidad and Tobago?
Your response must be concise. 6.22e+11. In the year 1972, what is the difference between the Imports (in Local Currency Unit) in Afghanistan and Imports (in Local Currency Unit) in Belgium?
Offer a terse response. -3.69e+09. In the year 1972, what is the difference between the Imports (in Local Currency Unit) in Afghanistan and Imports (in Local Currency Unit) in Indonesia?
Provide a short and direct response. -7.63e+11. In the year 1972, what is the difference between the Imports (in Local Currency Unit) of Afghanistan and Imports (in Local Currency Unit) of Trinidad and Tobago?
Make the answer very short. 1.20e+1. In the year 1972, what is the difference between the Imports (in Local Currency Unit) in Belgium and Imports (in Local Currency Unit) in Indonesia?
Provide a succinct answer. -7.59e+11. In the year 1972, what is the difference between the Imports (in Local Currency Unit) in Belgium and Imports (in Local Currency Unit) in Trinidad and Tobago?
Your answer should be very brief. 1.57e+1. In the year 1972, what is the difference between the Imports (in Local Currency Unit) of Indonesia and Imports (in Local Currency Unit) of Trinidad and Tobago?
Your answer should be compact. 7.75e+11. In the year 1973, what is the difference between the Imports (in Local Currency Unit) in Afghanistan and Imports (in Local Currency Unit) in Belgium?
Offer a terse response. -9.79e+09. In the year 1973, what is the difference between the Imports (in Local Currency Unit) in Afghanistan and Imports (in Local Currency Unit) in Indonesia?
Offer a very short reply. -1.32e+12. In the year 1973, what is the difference between the Imports (in Local Currency Unit) in Afghanistan and Imports (in Local Currency Unit) in Trinidad and Tobago?
Offer a terse response. 1.05e+1. In the year 1973, what is the difference between the Imports (in Local Currency Unit) in Belgium and Imports (in Local Currency Unit) in Indonesia?
Keep it short and to the point. -1.31e+12. In the year 1973, what is the difference between the Imports (in Local Currency Unit) of Belgium and Imports (in Local Currency Unit) of Trinidad and Tobago?
Keep it short and to the point. 2.03e+1. In the year 1973, what is the difference between the Imports (in Local Currency Unit) in Indonesia and Imports (in Local Currency Unit) in Trinidad and Tobago?
Offer a very short reply. 1.33e+12. In the year 1974, what is the difference between the Imports (in Local Currency Unit) of Afghanistan and Imports (in Local Currency Unit) of Belgium?
Give a very brief answer. -1.40e+1. In the year 1974, what is the difference between the Imports (in Local Currency Unit) of Afghanistan and Imports (in Local Currency Unit) of Indonesia?
Your answer should be very brief. -2.30e+12. In the year 1974, what is the difference between the Imports (in Local Currency Unit) of Afghanistan and Imports (in Local Currency Unit) of Trinidad and Tobago?
Your answer should be compact. 1.31e+1. In the year 1974, what is the difference between the Imports (in Local Currency Unit) in Belgium and Imports (in Local Currency Unit) in Indonesia?
Offer a terse response. -2.28e+12. In the year 1974, what is the difference between the Imports (in Local Currency Unit) in Belgium and Imports (in Local Currency Unit) in Trinidad and Tobago?
Offer a very short reply. 2.70e+1. In the year 1974, what is the difference between the Imports (in Local Currency Unit) in Indonesia and Imports (in Local Currency Unit) in Trinidad and Tobago?
Your answer should be compact. 2.31e+12. In the year 1975, what is the difference between the Imports (in Local Currency Unit) of Afghanistan and Imports (in Local Currency Unit) of Belgium?
Your response must be concise. -1.21e+1. In the year 1975, what is the difference between the Imports (in Local Currency Unit) in Afghanistan and Imports (in Local Currency Unit) in Indonesia?
Provide a short and direct response. -2.79e+12. In the year 1975, what is the difference between the Imports (in Local Currency Unit) of Afghanistan and Imports (in Local Currency Unit) of Trinidad and Tobago?
Offer a very short reply. 1.33e+1. In the year 1975, what is the difference between the Imports (in Local Currency Unit) in Belgium and Imports (in Local Currency Unit) in Indonesia?
Your answer should be compact. -2.78e+12. In the year 1975, what is the difference between the Imports (in Local Currency Unit) in Belgium and Imports (in Local Currency Unit) in Trinidad and Tobago?
Provide a succinct answer. 2.55e+1. In the year 1975, what is the difference between the Imports (in Local Currency Unit) of Indonesia and Imports (in Local Currency Unit) of Trinidad and Tobago?
Provide a succinct answer. 2.80e+12. In the year 1976, what is the difference between the Imports (in Local Currency Unit) of Afghanistan and Imports (in Local Currency Unit) of Belgium?
Your answer should be compact. -1.58e+1. In the year 1976, what is the difference between the Imports (in Local Currency Unit) in Afghanistan and Imports (in Local Currency Unit) in Indonesia?
Your response must be concise. -3.50e+12. In the year 1976, what is the difference between the Imports (in Local Currency Unit) of Afghanistan and Imports (in Local Currency Unit) of Trinidad and Tobago?
Your response must be concise. 1.47e+1. In the year 1976, what is the difference between the Imports (in Local Currency Unit) of Belgium and Imports (in Local Currency Unit) of Indonesia?
Give a very brief answer. -3.48e+12. In the year 1976, what is the difference between the Imports (in Local Currency Unit) in Belgium and Imports (in Local Currency Unit) in Trinidad and Tobago?
Your response must be concise. 3.04e+1. In the year 1976, what is the difference between the Imports (in Local Currency Unit) in Indonesia and Imports (in Local Currency Unit) in Trinidad and Tobago?
Offer a terse response. 3.51e+12. In the year 1977, what is the difference between the Imports (in Local Currency Unit) of Afghanistan and Imports (in Local Currency Unit) of Belgium?
Keep it short and to the point. -1.58e+1. In the year 1977, what is the difference between the Imports (in Local Currency Unit) in Afghanistan and Imports (in Local Currency Unit) in Indonesia?
Ensure brevity in your answer.  -3.84e+12. In the year 1977, what is the difference between the Imports (in Local Currency Unit) of Afghanistan and Imports (in Local Currency Unit) of Trinidad and Tobago?
Your response must be concise. 1.69e+1. In the year 1977, what is the difference between the Imports (in Local Currency Unit) of Belgium and Imports (in Local Currency Unit) of Indonesia?
Make the answer very short. -3.82e+12. In the year 1977, what is the difference between the Imports (in Local Currency Unit) of Belgium and Imports (in Local Currency Unit) of Trinidad and Tobago?
Ensure brevity in your answer.  3.27e+1. In the year 1977, what is the difference between the Imports (in Local Currency Unit) of Indonesia and Imports (in Local Currency Unit) of Trinidad and Tobago?
Your answer should be compact. 3.85e+12. What is the ratio of the Imports (in Local Currency Unit) of Afghanistan in 1971 to that in 1972?
Ensure brevity in your answer.  1.02. What is the ratio of the Imports (in Local Currency Unit) in Belgium in 1971 to that in 1972?
Your answer should be compact. 0.91. What is the ratio of the Imports (in Local Currency Unit) in Indonesia in 1971 to that in 1972?
Your answer should be very brief. 0.8. What is the ratio of the Imports (in Local Currency Unit) of Trinidad and Tobago in 1971 to that in 1972?
Your answer should be compact. 0.88. What is the ratio of the Imports (in Local Currency Unit) in Afghanistan in 1971 to that in 1973?
Your answer should be compact. 1.16. What is the ratio of the Imports (in Local Currency Unit) in Belgium in 1971 to that in 1973?
Offer a terse response. 0.71. What is the ratio of the Imports (in Local Currency Unit) in Indonesia in 1971 to that in 1973?
Make the answer very short. 0.47. What is the ratio of the Imports (in Local Currency Unit) in Trinidad and Tobago in 1971 to that in 1973?
Keep it short and to the point. 0.86. What is the ratio of the Imports (in Local Currency Unit) in Afghanistan in 1971 to that in 1974?
Ensure brevity in your answer.  0.92. What is the ratio of the Imports (in Local Currency Unit) of Belgium in 1971 to that in 1974?
Your answer should be compact. 0.54. What is the ratio of the Imports (in Local Currency Unit) of Indonesia in 1971 to that in 1974?
Offer a terse response. 0.27. What is the ratio of the Imports (in Local Currency Unit) in Trinidad and Tobago in 1971 to that in 1974?
Provide a succinct answer. 0.63. What is the ratio of the Imports (in Local Currency Unit) in Afghanistan in 1971 to that in 1975?
Make the answer very short. 0.88. What is the ratio of the Imports (in Local Currency Unit) of Belgium in 1971 to that in 1975?
Give a very brief answer. 0.56. What is the ratio of the Imports (in Local Currency Unit) in Indonesia in 1971 to that in 1975?
Offer a terse response. 0.22. What is the ratio of the Imports (in Local Currency Unit) in Trinidad and Tobago in 1971 to that in 1975?
Your answer should be compact. 0.45. What is the ratio of the Imports (in Local Currency Unit) of Afghanistan in 1971 to that in 1976?
Offer a terse response. 0.78. What is the ratio of the Imports (in Local Currency Unit) in Belgium in 1971 to that in 1976?
Your answer should be compact. 0.46. What is the ratio of the Imports (in Local Currency Unit) in Indonesia in 1971 to that in 1976?
Offer a terse response. 0.18. What is the ratio of the Imports (in Local Currency Unit) of Trinidad and Tobago in 1971 to that in 1976?
Your answer should be compact. 0.35. What is the ratio of the Imports (in Local Currency Unit) of Afghanistan in 1971 to that in 1977?
Your answer should be compact. 0.68. What is the ratio of the Imports (in Local Currency Unit) in Belgium in 1971 to that in 1977?
Offer a very short reply. 0.43. What is the ratio of the Imports (in Local Currency Unit) in Indonesia in 1971 to that in 1977?
Keep it short and to the point. 0.16. What is the ratio of the Imports (in Local Currency Unit) of Trinidad and Tobago in 1971 to that in 1977?
Your answer should be very brief. 0.31. What is the ratio of the Imports (in Local Currency Unit) in Afghanistan in 1972 to that in 1973?
Your answer should be compact. 1.13. What is the ratio of the Imports (in Local Currency Unit) of Belgium in 1972 to that in 1973?
Keep it short and to the point. 0.78. What is the ratio of the Imports (in Local Currency Unit) in Indonesia in 1972 to that in 1973?
Keep it short and to the point. 0.58. What is the ratio of the Imports (in Local Currency Unit) of Trinidad and Tobago in 1972 to that in 1973?
Keep it short and to the point. 0.98. What is the ratio of the Imports (in Local Currency Unit) of Afghanistan in 1972 to that in 1974?
Your response must be concise. 0.9. What is the ratio of the Imports (in Local Currency Unit) of Belgium in 1972 to that in 1974?
Offer a very short reply. 0.59. What is the ratio of the Imports (in Local Currency Unit) of Indonesia in 1972 to that in 1974?
Keep it short and to the point. 0.34. What is the ratio of the Imports (in Local Currency Unit) of Trinidad and Tobago in 1972 to that in 1974?
Provide a succinct answer. 0.71. What is the ratio of the Imports (in Local Currency Unit) of Afghanistan in 1972 to that in 1975?
Offer a very short reply. 0.86. What is the ratio of the Imports (in Local Currency Unit) of Belgium in 1972 to that in 1975?
Ensure brevity in your answer.  0.61. What is the ratio of the Imports (in Local Currency Unit) in Indonesia in 1972 to that in 1975?
Offer a very short reply. 0.28. What is the ratio of the Imports (in Local Currency Unit) in Trinidad and Tobago in 1972 to that in 1975?
Offer a very short reply. 0.52. What is the ratio of the Imports (in Local Currency Unit) of Afghanistan in 1972 to that in 1976?
Provide a short and direct response. 0.76. What is the ratio of the Imports (in Local Currency Unit) of Belgium in 1972 to that in 1976?
Ensure brevity in your answer.  0.51. What is the ratio of the Imports (in Local Currency Unit) of Indonesia in 1972 to that in 1976?
Give a very brief answer. 0.22. What is the ratio of the Imports (in Local Currency Unit) of Trinidad and Tobago in 1972 to that in 1976?
Offer a very short reply. 0.39. What is the ratio of the Imports (in Local Currency Unit) of Afghanistan in 1972 to that in 1977?
Provide a succinct answer. 0.66. What is the ratio of the Imports (in Local Currency Unit) of Belgium in 1972 to that in 1977?
Provide a short and direct response. 0.47. What is the ratio of the Imports (in Local Currency Unit) in Indonesia in 1972 to that in 1977?
Your response must be concise. 0.2. What is the ratio of the Imports (in Local Currency Unit) in Trinidad and Tobago in 1972 to that in 1977?
Give a very brief answer. 0.35. What is the ratio of the Imports (in Local Currency Unit) in Afghanistan in 1973 to that in 1974?
Provide a succinct answer. 0.8. What is the ratio of the Imports (in Local Currency Unit) of Belgium in 1973 to that in 1974?
Your answer should be compact. 0.75. What is the ratio of the Imports (in Local Currency Unit) in Indonesia in 1973 to that in 1974?
Offer a very short reply. 0.57. What is the ratio of the Imports (in Local Currency Unit) in Trinidad and Tobago in 1973 to that in 1974?
Ensure brevity in your answer.  0.73. What is the ratio of the Imports (in Local Currency Unit) in Afghanistan in 1973 to that in 1975?
Your response must be concise. 0.76. What is the ratio of the Imports (in Local Currency Unit) in Belgium in 1973 to that in 1975?
Make the answer very short. 0.78. What is the ratio of the Imports (in Local Currency Unit) of Indonesia in 1973 to that in 1975?
Offer a terse response. 0.47. What is the ratio of the Imports (in Local Currency Unit) of Trinidad and Tobago in 1973 to that in 1975?
Provide a short and direct response. 0.53. What is the ratio of the Imports (in Local Currency Unit) in Afghanistan in 1973 to that in 1976?
Keep it short and to the point. 0.67. What is the ratio of the Imports (in Local Currency Unit) of Belgium in 1973 to that in 1976?
Provide a short and direct response. 0.65. What is the ratio of the Imports (in Local Currency Unit) in Indonesia in 1973 to that in 1976?
Offer a very short reply. 0.38. What is the ratio of the Imports (in Local Currency Unit) of Trinidad and Tobago in 1973 to that in 1976?
Ensure brevity in your answer.  0.4. What is the ratio of the Imports (in Local Currency Unit) in Afghanistan in 1973 to that in 1977?
Provide a short and direct response. 0.58. What is the ratio of the Imports (in Local Currency Unit) in Belgium in 1973 to that in 1977?
Make the answer very short. 0.6. What is the ratio of the Imports (in Local Currency Unit) in Indonesia in 1973 to that in 1977?
Your answer should be very brief. 0.34. What is the ratio of the Imports (in Local Currency Unit) in Trinidad and Tobago in 1973 to that in 1977?
Your answer should be very brief. 0.35. What is the ratio of the Imports (in Local Currency Unit) of Afghanistan in 1974 to that in 1975?
Ensure brevity in your answer.  0.95. What is the ratio of the Imports (in Local Currency Unit) in Belgium in 1974 to that in 1975?
Ensure brevity in your answer.  1.04. What is the ratio of the Imports (in Local Currency Unit) in Indonesia in 1974 to that in 1975?
Keep it short and to the point. 0.82. What is the ratio of the Imports (in Local Currency Unit) in Trinidad and Tobago in 1974 to that in 1975?
Your answer should be compact. 0.72. What is the ratio of the Imports (in Local Currency Unit) in Afghanistan in 1974 to that in 1976?
Your answer should be compact. 0.84. What is the ratio of the Imports (in Local Currency Unit) of Belgium in 1974 to that in 1976?
Offer a terse response. 0.86. What is the ratio of the Imports (in Local Currency Unit) of Indonesia in 1974 to that in 1976?
Offer a terse response. 0.66. What is the ratio of the Imports (in Local Currency Unit) of Trinidad and Tobago in 1974 to that in 1976?
Keep it short and to the point. 0.55. What is the ratio of the Imports (in Local Currency Unit) in Afghanistan in 1974 to that in 1977?
Keep it short and to the point. 0.73. What is the ratio of the Imports (in Local Currency Unit) in Belgium in 1974 to that in 1977?
Offer a terse response. 0.8. What is the ratio of the Imports (in Local Currency Unit) in Indonesia in 1974 to that in 1977?
Offer a terse response. 0.6. What is the ratio of the Imports (in Local Currency Unit) of Trinidad and Tobago in 1974 to that in 1977?
Provide a short and direct response. 0.49. What is the ratio of the Imports (in Local Currency Unit) of Belgium in 1975 to that in 1976?
Your response must be concise. 0.83. What is the ratio of the Imports (in Local Currency Unit) in Indonesia in 1975 to that in 1976?
Offer a terse response. 0.8. What is the ratio of the Imports (in Local Currency Unit) of Trinidad and Tobago in 1975 to that in 1976?
Give a very brief answer. 0.76. What is the ratio of the Imports (in Local Currency Unit) of Afghanistan in 1975 to that in 1977?
Provide a short and direct response. 0.77. What is the ratio of the Imports (in Local Currency Unit) in Belgium in 1975 to that in 1977?
Ensure brevity in your answer.  0.77. What is the ratio of the Imports (in Local Currency Unit) of Indonesia in 1975 to that in 1977?
Give a very brief answer. 0.73. What is the ratio of the Imports (in Local Currency Unit) in Trinidad and Tobago in 1975 to that in 1977?
Your answer should be very brief. 0.67. What is the ratio of the Imports (in Local Currency Unit) of Afghanistan in 1976 to that in 1977?
Provide a succinct answer. 0.87. What is the ratio of the Imports (in Local Currency Unit) in Belgium in 1976 to that in 1977?
Keep it short and to the point. 0.93. What is the ratio of the Imports (in Local Currency Unit) of Indonesia in 1976 to that in 1977?
Make the answer very short. 0.91. What is the ratio of the Imports (in Local Currency Unit) in Trinidad and Tobago in 1976 to that in 1977?
Your response must be concise. 0.88. What is the difference between the highest and the second highest Imports (in Local Currency Unit) of Afghanistan?
Provide a succinct answer. 2.60e+09. What is the difference between the highest and the second highest Imports (in Local Currency Unit) of Belgium?
Provide a succinct answer. 2.61e+09. What is the difference between the highest and the second highest Imports (in Local Currency Unit) in Indonesia?
Provide a succinct answer. 3.42e+11. What is the difference between the highest and the second highest Imports (in Local Currency Unit) in Trinidad and Tobago?
Your answer should be compact. 3.35e+08. What is the difference between the highest and the lowest Imports (in Local Currency Unit) in Afghanistan?
Your response must be concise. 8.20e+09. What is the difference between the highest and the lowest Imports (in Local Currency Unit) in Belgium?
Provide a short and direct response. 2.03e+1. What is the difference between the highest and the lowest Imports (in Local Currency Unit) of Indonesia?
Provide a succinct answer. 3.23e+12. What is the difference between the highest and the lowest Imports (in Local Currency Unit) in Trinidad and Tobago?
Make the answer very short. 1.93e+09. 